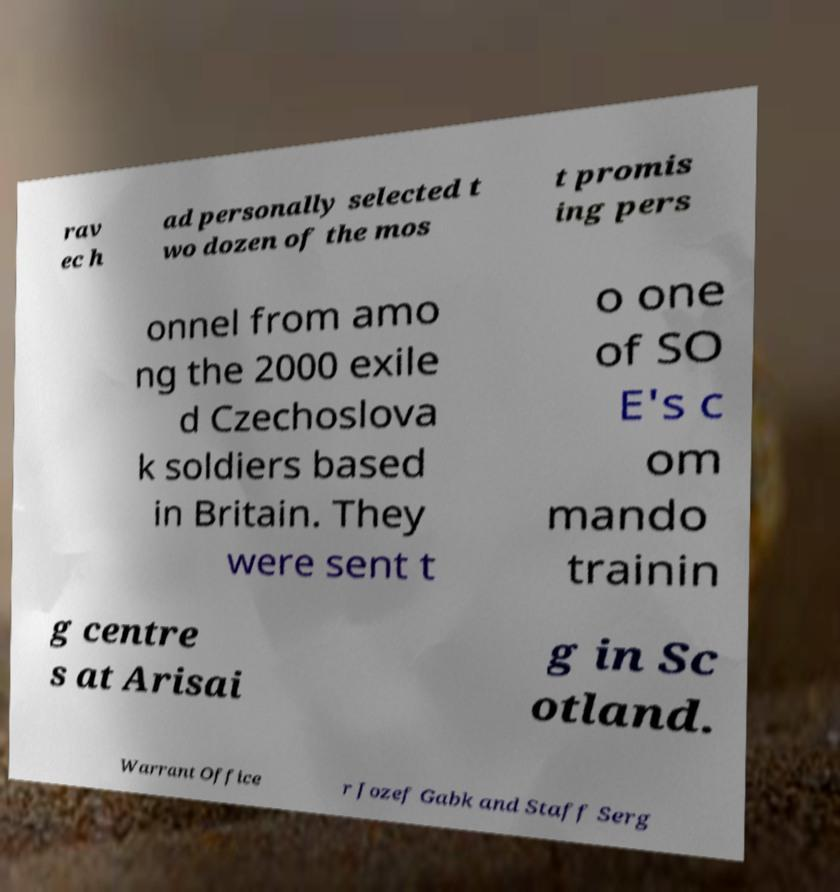For documentation purposes, I need the text within this image transcribed. Could you provide that? rav ec h ad personally selected t wo dozen of the mos t promis ing pers onnel from amo ng the 2000 exile d Czechoslova k soldiers based in Britain. They were sent t o one of SO E's c om mando trainin g centre s at Arisai g in Sc otland. Warrant Office r Jozef Gabk and Staff Serg 